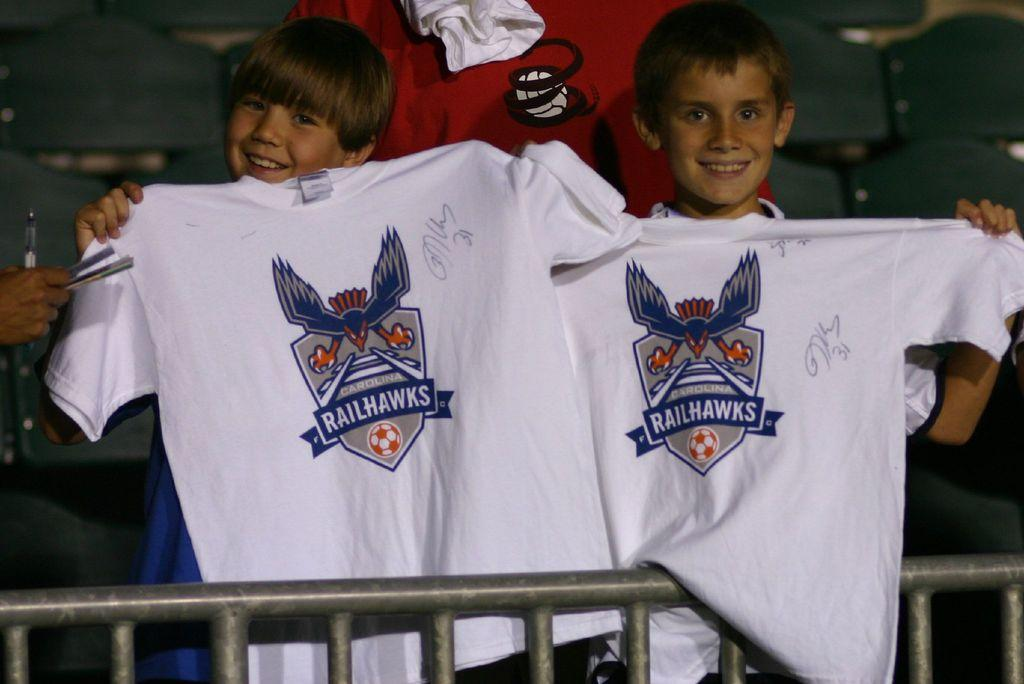<image>
Render a clear and concise summary of the photo. Two kids holds up white autographed Railhawks t-shirts. 